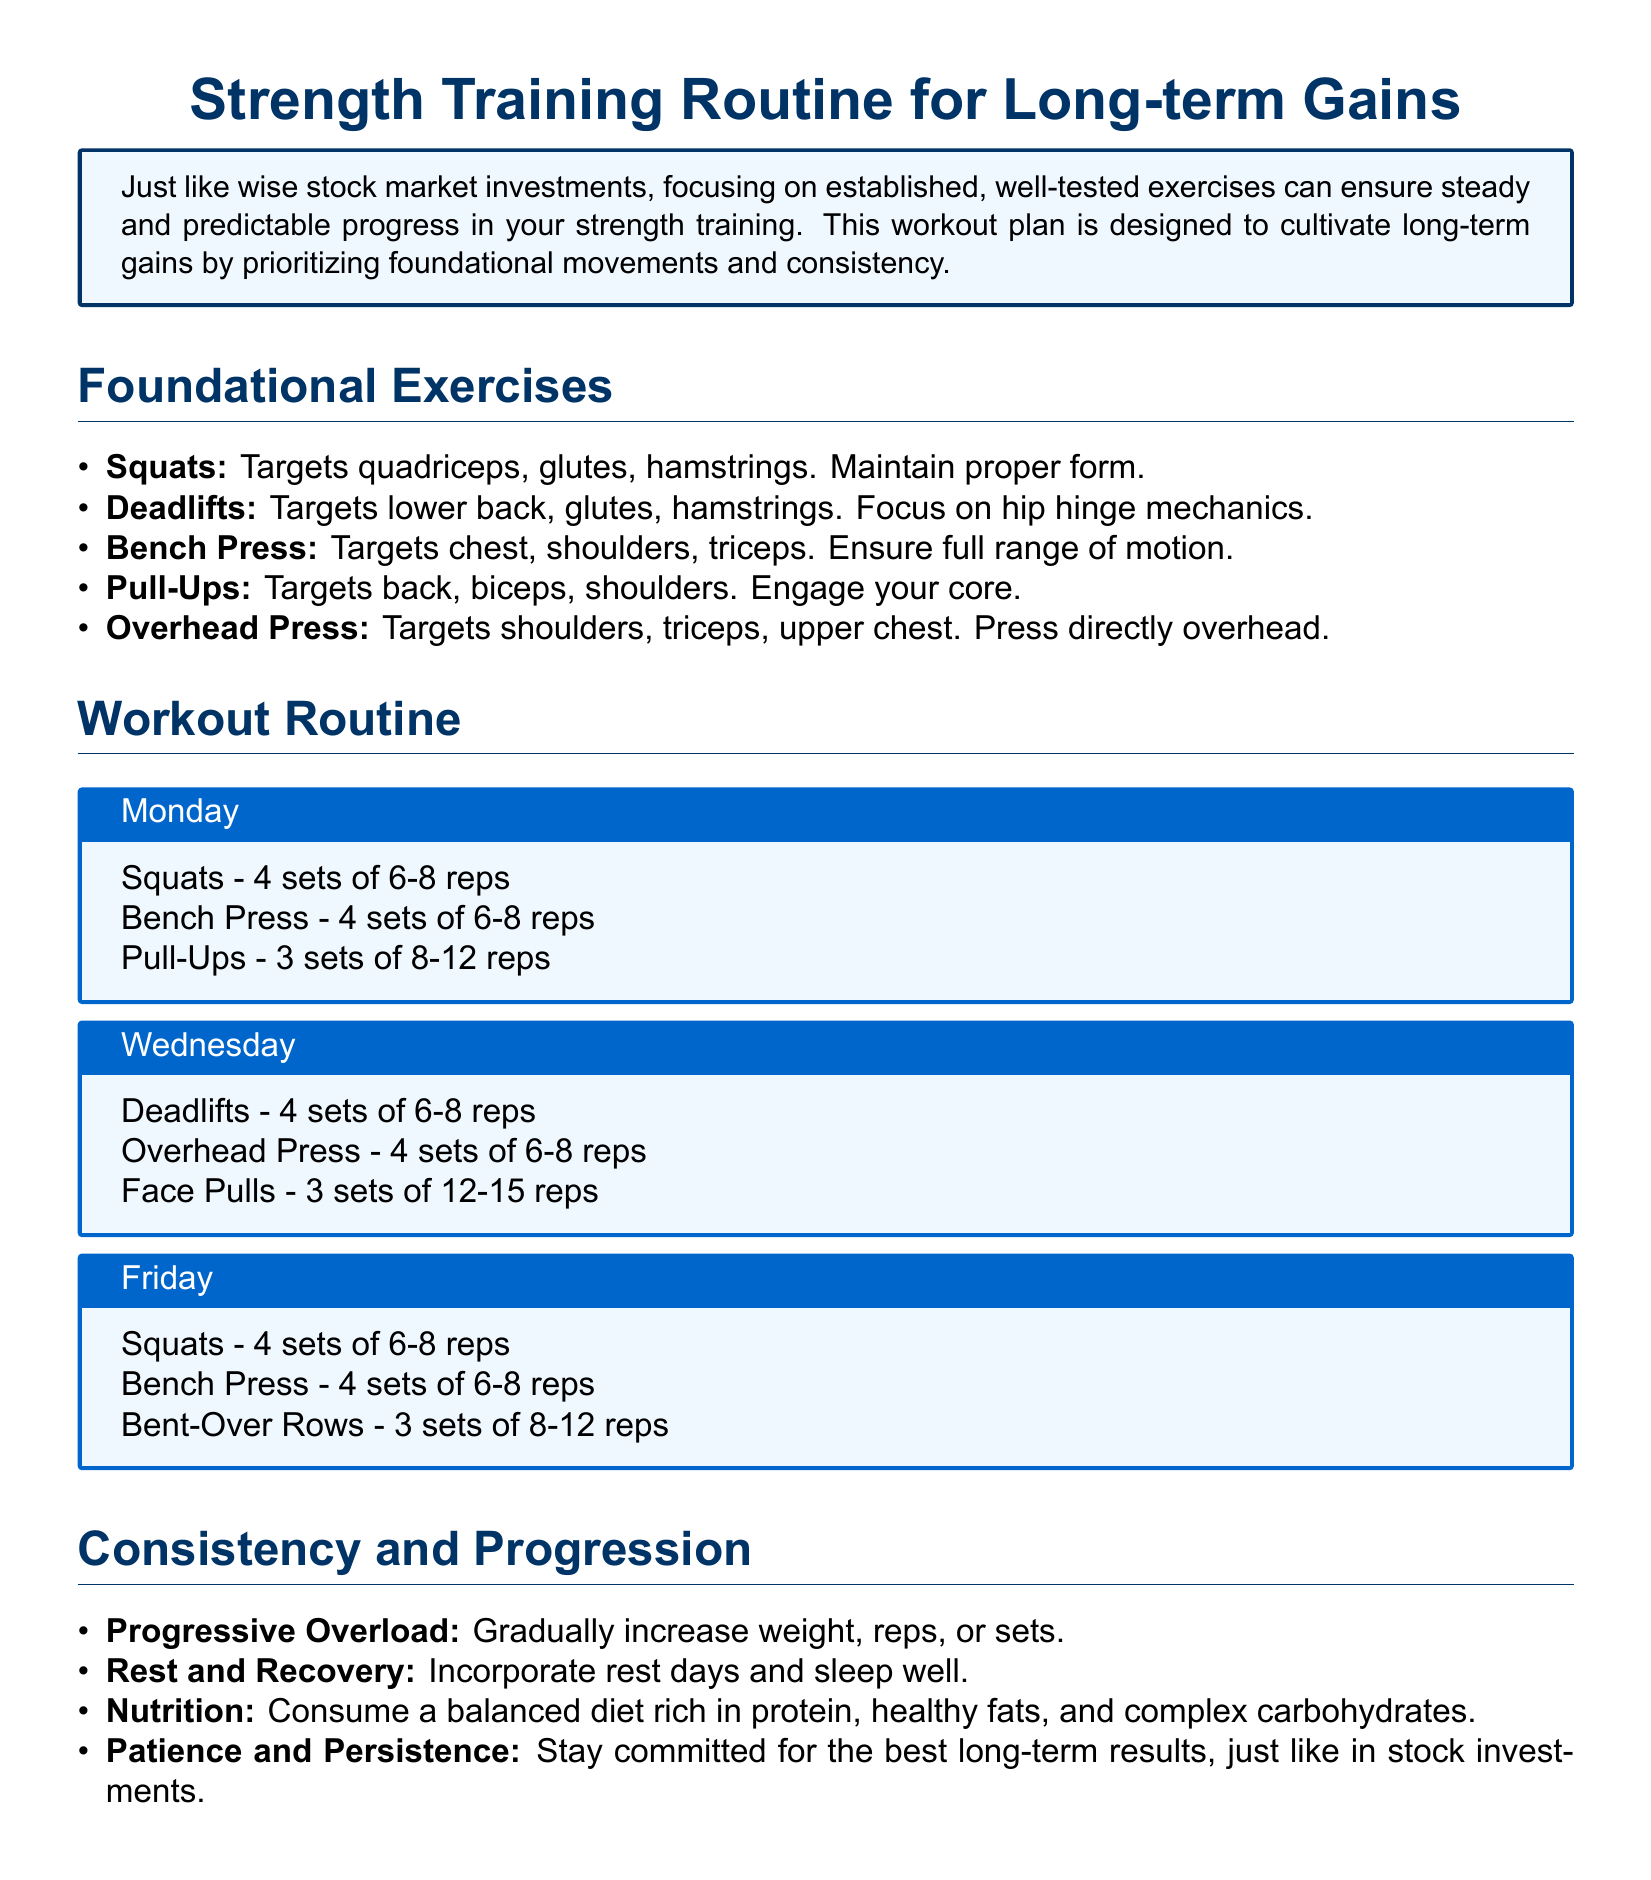What are the foundational exercises listed? The foundational exercises are explicitly mentioned in the document and include Squats, Deadlifts, Bench Press, Pull-Ups, and Overhead Press.
Answer: Squats, Deadlifts, Bench Press, Pull-Ups, Overhead Press How many sets of Deadlifts are prescribed for Wednesday? The document specifies that there are 4 sets of Deadlifts for the Wednesday workout routine.
Answer: 4 sets What is a key component of the workout routine that ensures long-term gains? The document emphasizes "Progressive Overload" as a critical element for continual progress in the workout plan.
Answer: Progressive Overload Which day's workout includes Face Pulls? The document provides details of the workout days, indicating that Face Pulls are specifically included in the Wednesday workout.
Answer: Wednesday What should be emphasized along with rest and recovery? The document mentions nutrition as an important factor alongside rest and recovery in the context of strength training.
Answer: Nutrition How many reps are recommended for Pull-Ups on Monday? The document indicates that Pull-Ups should be performed for 3 sets of 8-12 reps on Monday.
Answer: 8-12 reps What should be the focus during the execution of Deadlifts? Proper form is emphasized in the document, particularly focusing on hip hinge mechanics when performing Deadlifts.
Answer: Hip hinge mechanics 